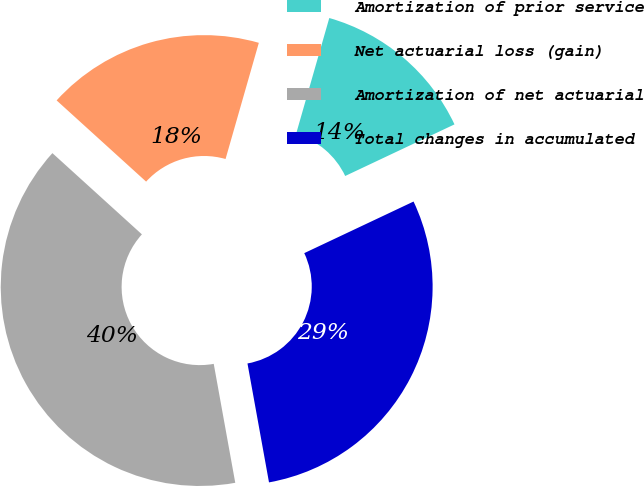Convert chart to OTSL. <chart><loc_0><loc_0><loc_500><loc_500><pie_chart><fcel>Amortization of prior service<fcel>Net actuarial loss (gain)<fcel>Amortization of net actuarial<fcel>Total changes in accumulated<nl><fcel>13.54%<fcel>17.71%<fcel>39.58%<fcel>29.17%<nl></chart> 